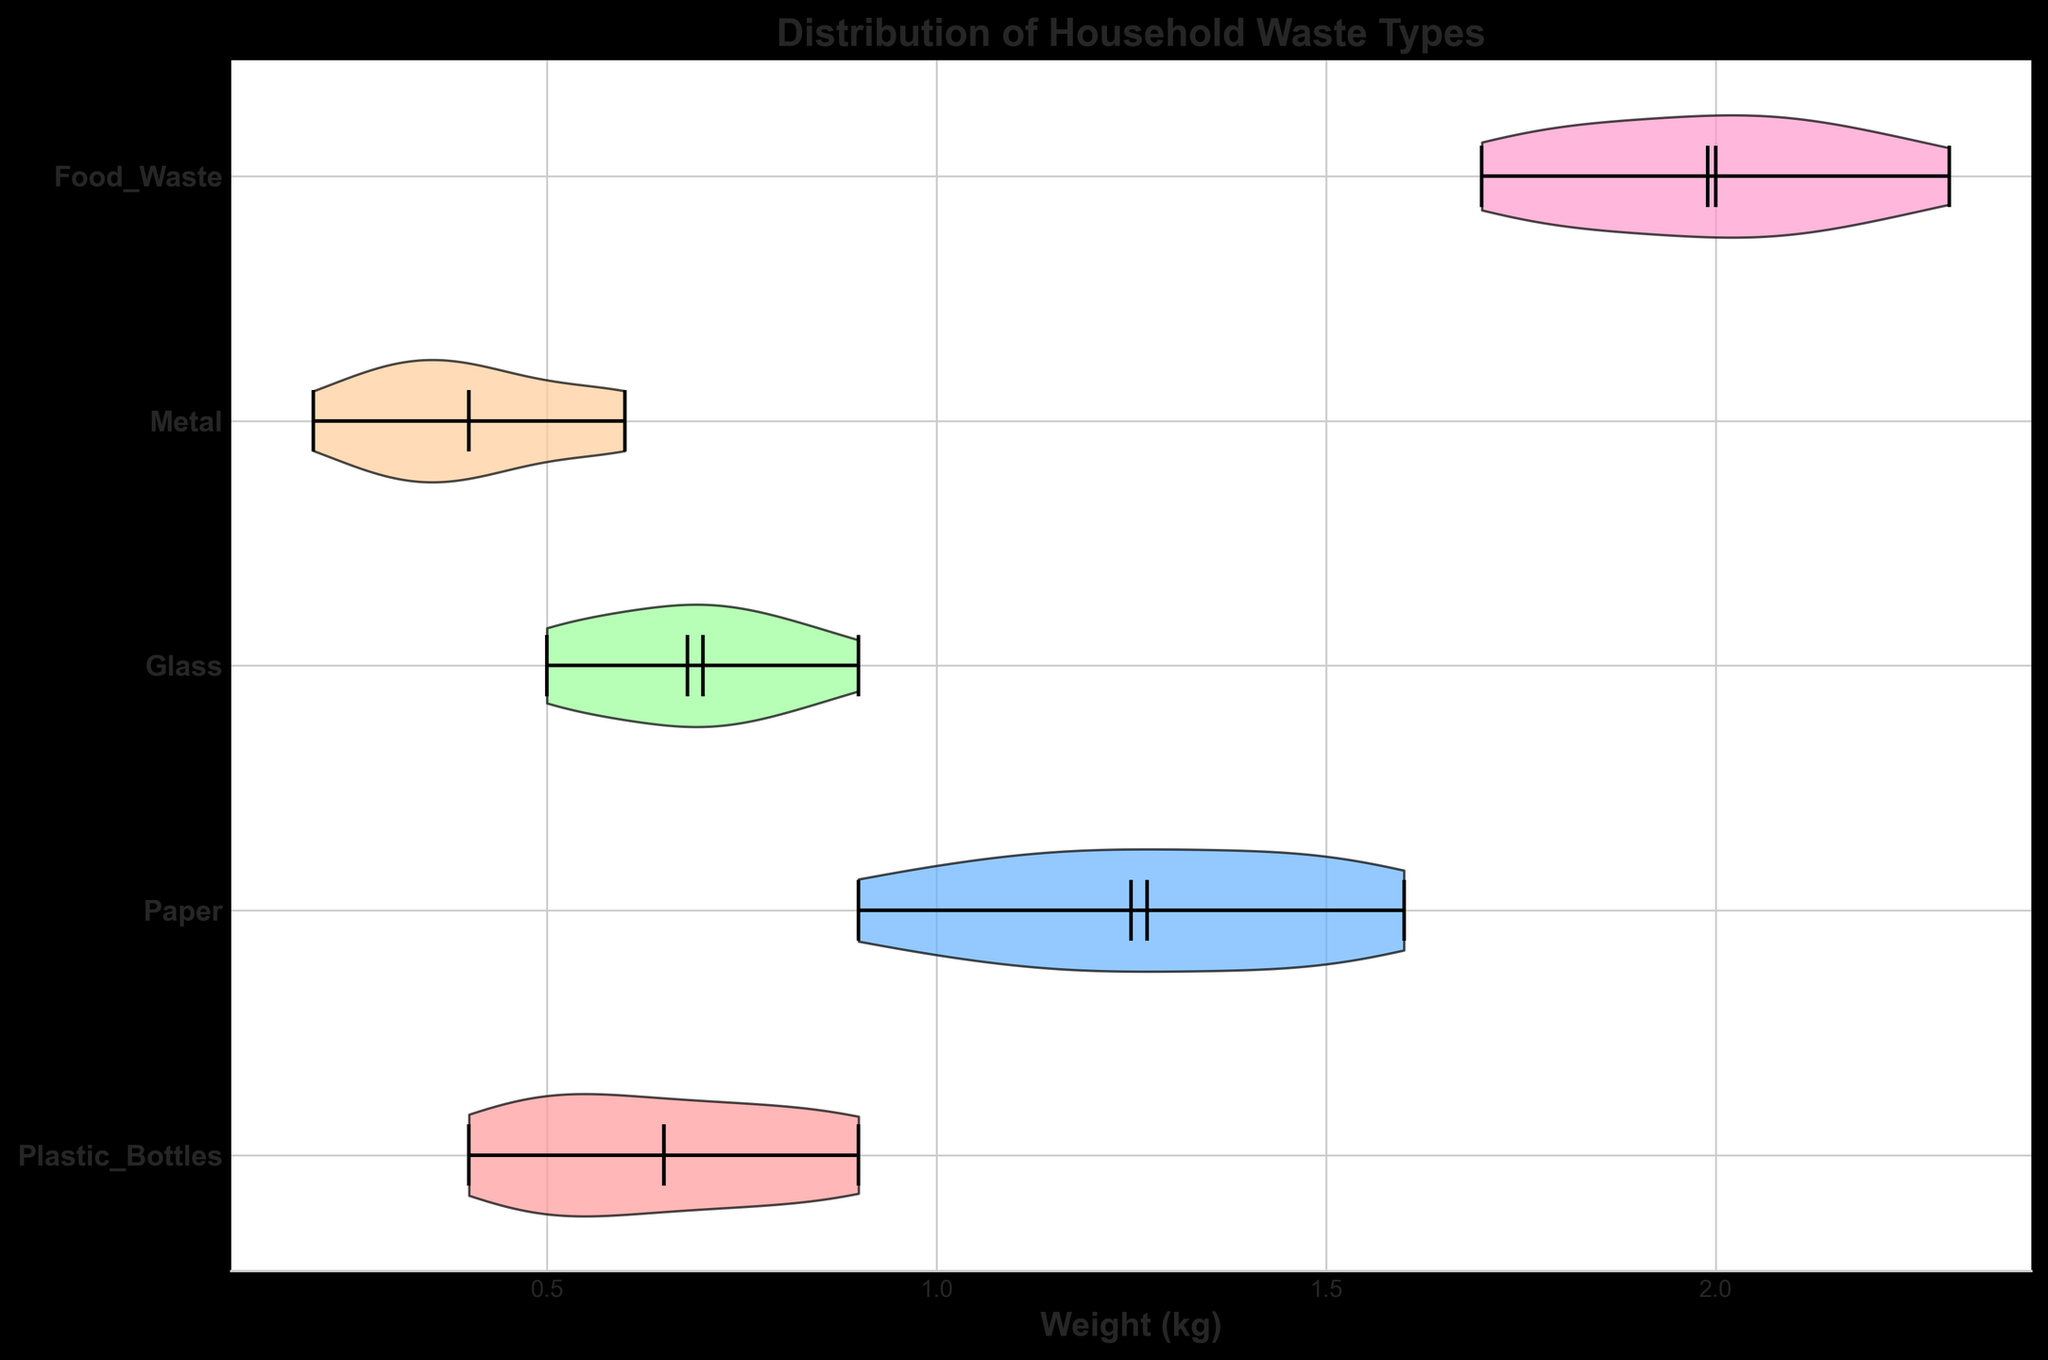What is the title of the chart? The title of the chart is located at the top and gives an overview of what the figure represents. In this case, it indicates what the chart is about.
Answer: Distribution of Household Waste Types Which waste type has the widest distribution of weights? The width of the violin plots indicates the distribution of weights. The widest violin plot shows the waste type with the largest spread.
Answer: Food Waste What is the median weight of Paper in kilograms? The median is marked by a line within the violin plot. By examining the Paper plot, the median can be identified.
Answer: 1.2 kg How does the mean weight of Glass compare to the mean weight of Metal? The means are marked by a point in the middle of the violin plots. Comparing the positions of these points for Glass and Metal will reveal which one is higher.
Answer: Glass has a higher mean than Metal Which wastes have a higher median weight compared to Plastic Bottles? To answer this, look at the median lines of all waste types and identify those above the median line for Plastic Bottles.
Answer: Paper, Food Waste What is the range of weights for Metal? The range can be determined by identifying the lowest and highest points within the violin plot for Metal.
Answer: 0.2 kg to 0.6 kg Which waste type has the smallest average weight? The smallest average weight is indicated by the mean points. Finding the lowest mean point will answer this.
Answer: Metal How many waste types have their median weight above 1.0 kg? Count the number of violin plots where the median line is above the 1.0 kg mark on the x-axis.
Answer: 3 What is the approximate interquartile range (IQR) for Food Waste? The IQR is represented by the spread of the violin body. The wider part around the middle indicates the interquartile range.
Answer: Approximately 1.7 kg to 2.3 kg If the highest weight for Plastic Bottles is 0.9 kg, which waste types have weights exceeding this value? Compare the highest points on the violin plots of other waste types to the given 0.9 kg limit.
Answer: Paper, Food Waste 